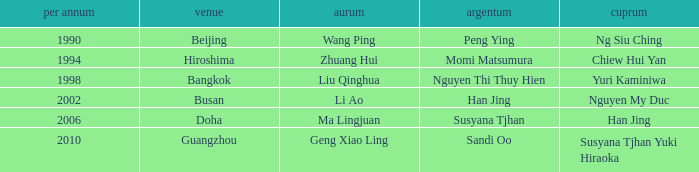Could you parse the entire table as a dict? {'header': ['per annum', 'venue', 'aurum', 'argentum', 'cuprum'], 'rows': [['1990', 'Beijing', 'Wang Ping', 'Peng Ying', 'Ng Siu Ching'], ['1994', 'Hiroshima', 'Zhuang Hui', 'Momi Matsumura', 'Chiew Hui Yan'], ['1998', 'Bangkok', 'Liu Qinghua', 'Nguyen Thi Thuy Hien', 'Yuri Kaminiwa'], ['2002', 'Busan', 'Li Ao', 'Han Jing', 'Nguyen My Duc'], ['2006', 'Doha', 'Ma Lingjuan', 'Susyana Tjhan', 'Han Jing'], ['2010', 'Guangzhou', 'Geng Xiao Ling', 'Sandi Oo', 'Susyana Tjhan Yuki Hiraoka']]} What Gold has the Year of 2006? Ma Lingjuan. 